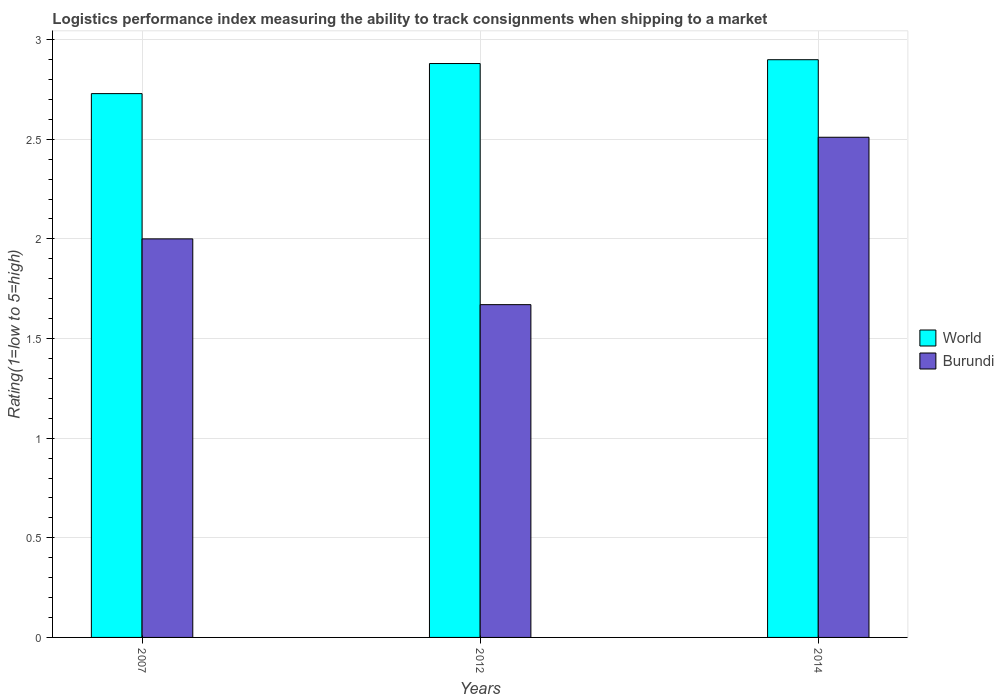How many different coloured bars are there?
Give a very brief answer. 2. What is the Logistic performance index in Burundi in 2012?
Offer a very short reply. 1.67. Across all years, what is the maximum Logistic performance index in World?
Offer a very short reply. 2.9. Across all years, what is the minimum Logistic performance index in World?
Your response must be concise. 2.73. What is the total Logistic performance index in Burundi in the graph?
Offer a terse response. 6.18. What is the difference between the Logistic performance index in Burundi in 2012 and that in 2014?
Keep it short and to the point. -0.84. What is the difference between the Logistic performance index in World in 2014 and the Logistic performance index in Burundi in 2012?
Offer a very short reply. 1.23. What is the average Logistic performance index in World per year?
Offer a very short reply. 2.84. In the year 2014, what is the difference between the Logistic performance index in Burundi and Logistic performance index in World?
Ensure brevity in your answer.  -0.39. What is the ratio of the Logistic performance index in World in 2007 to that in 2012?
Offer a very short reply. 0.95. What is the difference between the highest and the second highest Logistic performance index in Burundi?
Give a very brief answer. 0.51. What is the difference between the highest and the lowest Logistic performance index in Burundi?
Your answer should be very brief. 0.84. How many bars are there?
Give a very brief answer. 6. Are the values on the major ticks of Y-axis written in scientific E-notation?
Ensure brevity in your answer.  No. Does the graph contain grids?
Provide a succinct answer. Yes. How many legend labels are there?
Make the answer very short. 2. How are the legend labels stacked?
Your answer should be compact. Vertical. What is the title of the graph?
Give a very brief answer. Logistics performance index measuring the ability to track consignments when shipping to a market. Does "Honduras" appear as one of the legend labels in the graph?
Make the answer very short. No. What is the label or title of the Y-axis?
Your response must be concise. Rating(1=low to 5=high). What is the Rating(1=low to 5=high) in World in 2007?
Your answer should be very brief. 2.73. What is the Rating(1=low to 5=high) in World in 2012?
Your response must be concise. 2.88. What is the Rating(1=low to 5=high) in Burundi in 2012?
Ensure brevity in your answer.  1.67. What is the Rating(1=low to 5=high) in World in 2014?
Give a very brief answer. 2.9. What is the Rating(1=low to 5=high) in Burundi in 2014?
Your answer should be compact. 2.51. Across all years, what is the maximum Rating(1=low to 5=high) in World?
Your answer should be compact. 2.9. Across all years, what is the maximum Rating(1=low to 5=high) in Burundi?
Offer a very short reply. 2.51. Across all years, what is the minimum Rating(1=low to 5=high) of World?
Offer a very short reply. 2.73. Across all years, what is the minimum Rating(1=low to 5=high) in Burundi?
Ensure brevity in your answer.  1.67. What is the total Rating(1=low to 5=high) in World in the graph?
Keep it short and to the point. 8.51. What is the total Rating(1=low to 5=high) in Burundi in the graph?
Make the answer very short. 6.18. What is the difference between the Rating(1=low to 5=high) of World in 2007 and that in 2012?
Offer a very short reply. -0.15. What is the difference between the Rating(1=low to 5=high) in Burundi in 2007 and that in 2012?
Provide a succinct answer. 0.33. What is the difference between the Rating(1=low to 5=high) in World in 2007 and that in 2014?
Your answer should be very brief. -0.17. What is the difference between the Rating(1=low to 5=high) of Burundi in 2007 and that in 2014?
Give a very brief answer. -0.51. What is the difference between the Rating(1=low to 5=high) of World in 2012 and that in 2014?
Make the answer very short. -0.02. What is the difference between the Rating(1=low to 5=high) in Burundi in 2012 and that in 2014?
Offer a terse response. -0.84. What is the difference between the Rating(1=low to 5=high) of World in 2007 and the Rating(1=low to 5=high) of Burundi in 2012?
Offer a terse response. 1.06. What is the difference between the Rating(1=low to 5=high) in World in 2007 and the Rating(1=low to 5=high) in Burundi in 2014?
Keep it short and to the point. 0.22. What is the difference between the Rating(1=low to 5=high) of World in 2012 and the Rating(1=low to 5=high) of Burundi in 2014?
Provide a short and direct response. 0.37. What is the average Rating(1=low to 5=high) of World per year?
Your answer should be very brief. 2.84. What is the average Rating(1=low to 5=high) of Burundi per year?
Give a very brief answer. 2.06. In the year 2007, what is the difference between the Rating(1=low to 5=high) in World and Rating(1=low to 5=high) in Burundi?
Provide a short and direct response. 0.73. In the year 2012, what is the difference between the Rating(1=low to 5=high) in World and Rating(1=low to 5=high) in Burundi?
Ensure brevity in your answer.  1.21. In the year 2014, what is the difference between the Rating(1=low to 5=high) of World and Rating(1=low to 5=high) of Burundi?
Your answer should be compact. 0.39. What is the ratio of the Rating(1=low to 5=high) of World in 2007 to that in 2012?
Make the answer very short. 0.95. What is the ratio of the Rating(1=low to 5=high) in Burundi in 2007 to that in 2012?
Ensure brevity in your answer.  1.2. What is the ratio of the Rating(1=low to 5=high) of World in 2007 to that in 2014?
Give a very brief answer. 0.94. What is the ratio of the Rating(1=low to 5=high) in Burundi in 2007 to that in 2014?
Give a very brief answer. 0.8. What is the ratio of the Rating(1=low to 5=high) of Burundi in 2012 to that in 2014?
Ensure brevity in your answer.  0.67. What is the difference between the highest and the second highest Rating(1=low to 5=high) in World?
Your answer should be compact. 0.02. What is the difference between the highest and the second highest Rating(1=low to 5=high) in Burundi?
Your response must be concise. 0.51. What is the difference between the highest and the lowest Rating(1=low to 5=high) in World?
Your response must be concise. 0.17. What is the difference between the highest and the lowest Rating(1=low to 5=high) of Burundi?
Give a very brief answer. 0.84. 